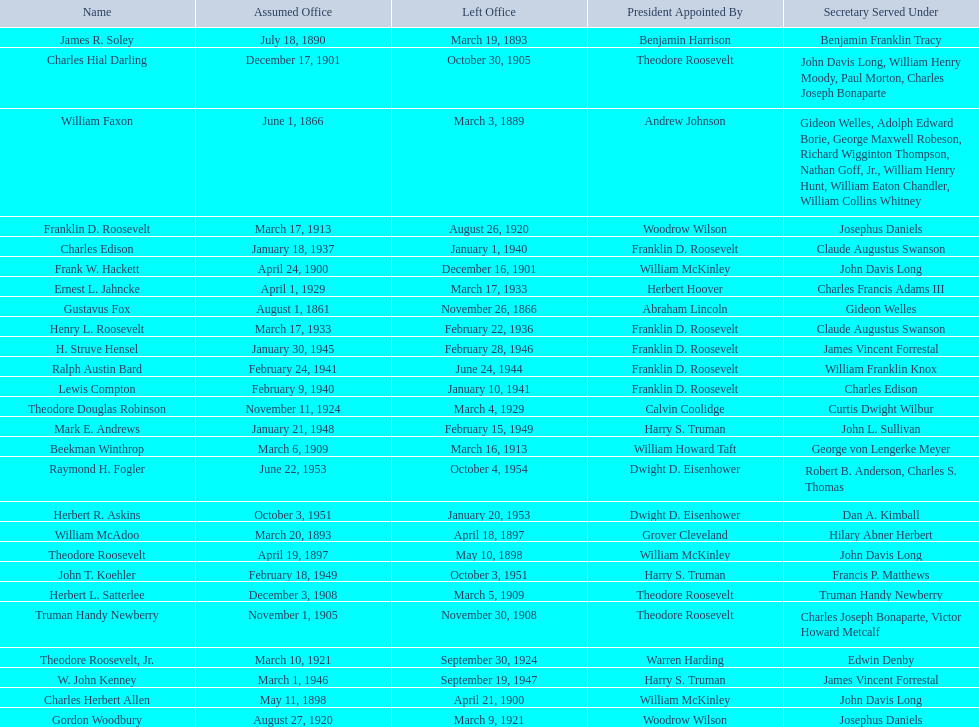Who were all the assistant secretary's of the navy? Gustavus Fox, William Faxon, James R. Soley, William McAdoo, Theodore Roosevelt, Charles Herbert Allen, Frank W. Hackett, Charles Hial Darling, Truman Handy Newberry, Herbert L. Satterlee, Beekman Winthrop, Franklin D. Roosevelt, Gordon Woodbury, Theodore Roosevelt, Jr., Theodore Douglas Robinson, Ernest L. Jahncke, Henry L. Roosevelt, Charles Edison, Lewis Compton, Ralph Austin Bard, H. Struve Hensel, W. John Kenney, Mark E. Andrews, John T. Koehler, Herbert R. Askins, Raymond H. Fogler. What are the various dates they left office in? November 26, 1866, March 3, 1889, March 19, 1893, April 18, 1897, May 10, 1898, April 21, 1900, December 16, 1901, October 30, 1905, November 30, 1908, March 5, 1909, March 16, 1913, August 26, 1920, March 9, 1921, September 30, 1924, March 4, 1929, March 17, 1933, February 22, 1936, January 1, 1940, January 10, 1941, June 24, 1944, February 28, 1946, September 19, 1947, February 15, 1949, October 3, 1951, January 20, 1953, October 4, 1954. Of these dates, which was the date raymond h. fogler left office in? October 4, 1954. 